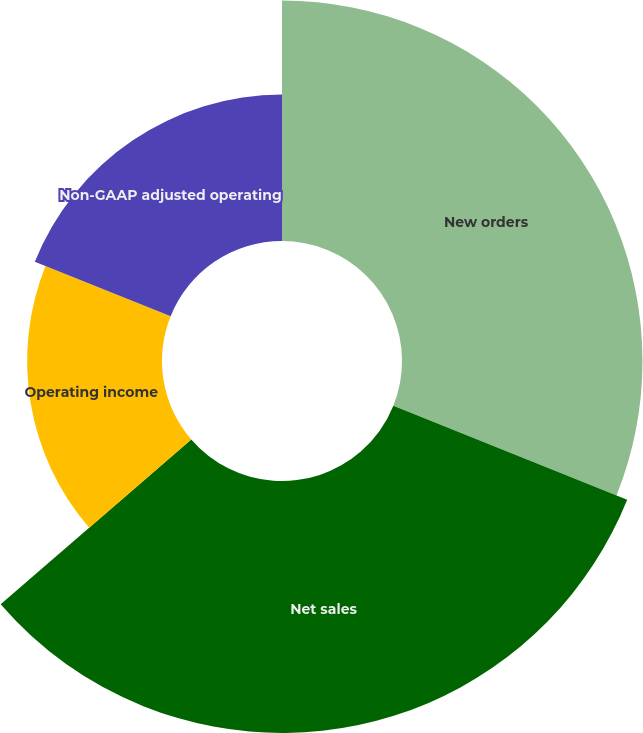Convert chart. <chart><loc_0><loc_0><loc_500><loc_500><pie_chart><fcel>New orders<fcel>Net sales<fcel>Operating income<fcel>Non-GAAP adjusted operating<nl><fcel>31.08%<fcel>32.57%<fcel>17.43%<fcel>18.92%<nl></chart> 